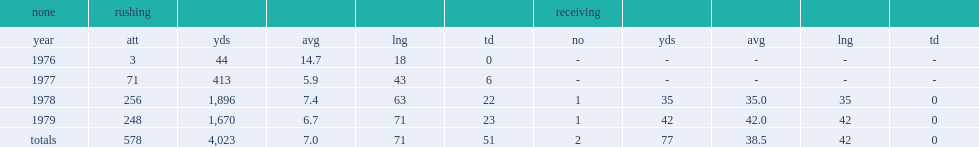How many rushing yards did sims have in 1978? 1896.0. 